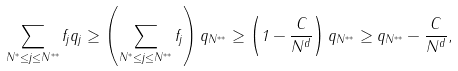<formula> <loc_0><loc_0><loc_500><loc_500>\sum _ { N ^ { * } \leq j \leq N ^ { * * } } f _ { j } q _ { j } \geq \left ( \sum _ { N ^ { * } \leq j \leq N ^ { * * } } f _ { j } \right ) q _ { N ^ { * * } } \geq \left ( 1 - \frac { C } { N ^ { d } } \right ) q _ { N ^ { * * } } \geq q _ { N ^ { * * } } - \frac { C } { N ^ { d } } ,</formula> 